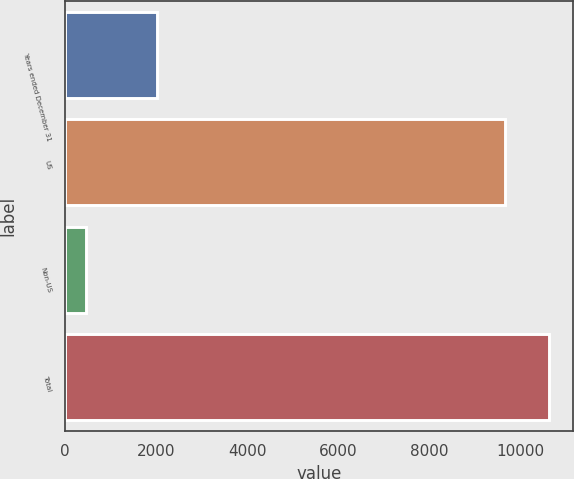Convert chart to OTSL. <chart><loc_0><loc_0><loc_500><loc_500><bar_chart><fcel>Years ended December 31<fcel>US<fcel>Non-US<fcel>Total<nl><fcel>2017<fcel>9660<fcel>447<fcel>10626<nl></chart> 